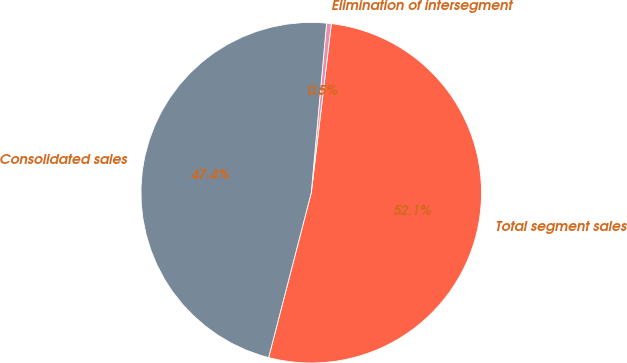Convert chart. <chart><loc_0><loc_0><loc_500><loc_500><pie_chart><fcel>Total segment sales<fcel>Elimination of intersegment<fcel>Consolidated sales<nl><fcel>52.14%<fcel>0.45%<fcel>47.4%<nl></chart> 